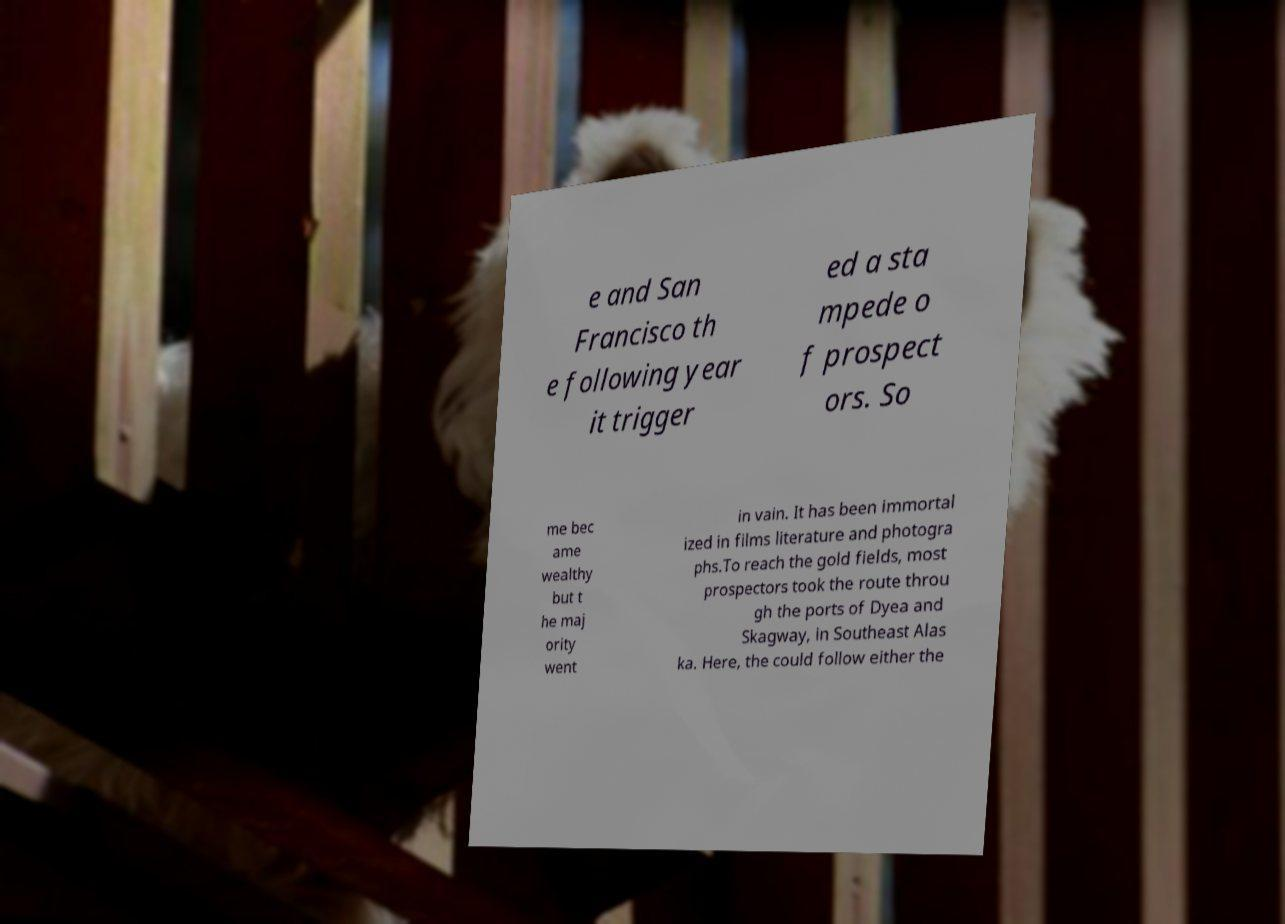Can you accurately transcribe the text from the provided image for me? e and San Francisco th e following year it trigger ed a sta mpede o f prospect ors. So me bec ame wealthy but t he maj ority went in vain. It has been immortal ized in films literature and photogra phs.To reach the gold fields, most prospectors took the route throu gh the ports of Dyea and Skagway, in Southeast Alas ka. Here, the could follow either the 